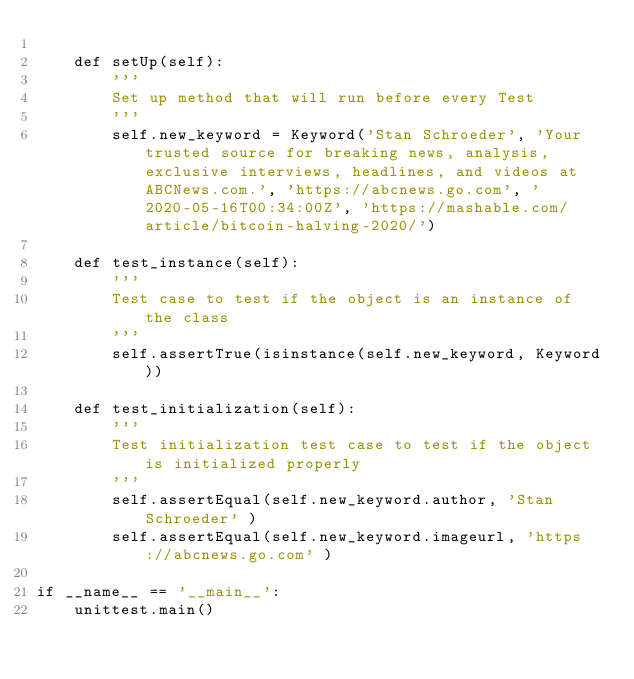<code> <loc_0><loc_0><loc_500><loc_500><_Python_>
    def setUp(self):
        '''
        Set up method that will run before every Test
        '''
        self.new_keyword = Keyword('Stan Schroeder', 'Your trusted source for breaking news, analysis, exclusive interviews, headlines, and videos at ABCNews.com.', 'https://abcnews.go.com', '2020-05-16T00:34:00Z', 'https://mashable.com/article/bitcoin-halving-2020/')

    def test_instance(self):
        '''
        Test case to test if the object is an instance of the class
        '''
        self.assertTrue(isinstance(self.new_keyword, Keyword))

    def test_initialization(self):
        '''
        Test initialization test case to test if the object is initialized properly
        '''
        self.assertEqual(self.new_keyword.author, 'Stan Schroeder' )
        self.assertEqual(self.new_keyword.imageurl, 'https://abcnews.go.com' )

if __name__ == '__main__':
    unittest.main()
    
</code> 